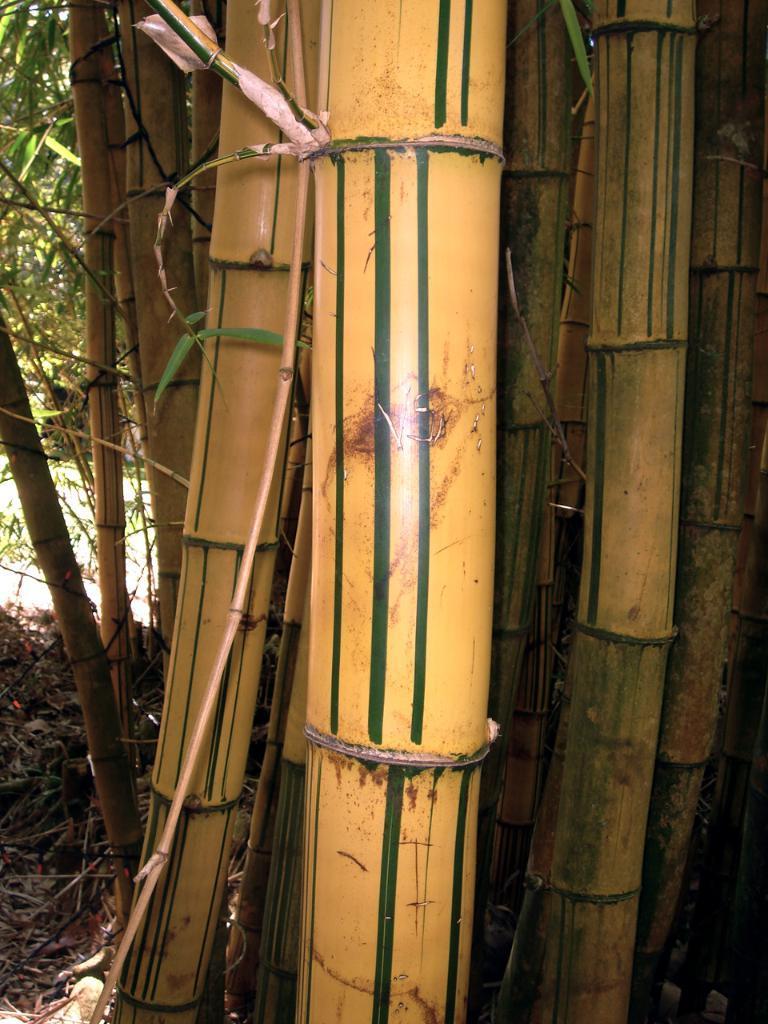Describe this image in one or two sentences. In this image I can see few bamboo sticks which are yellow and green in color. In the background I can see few trees which are green in color and the ground. 